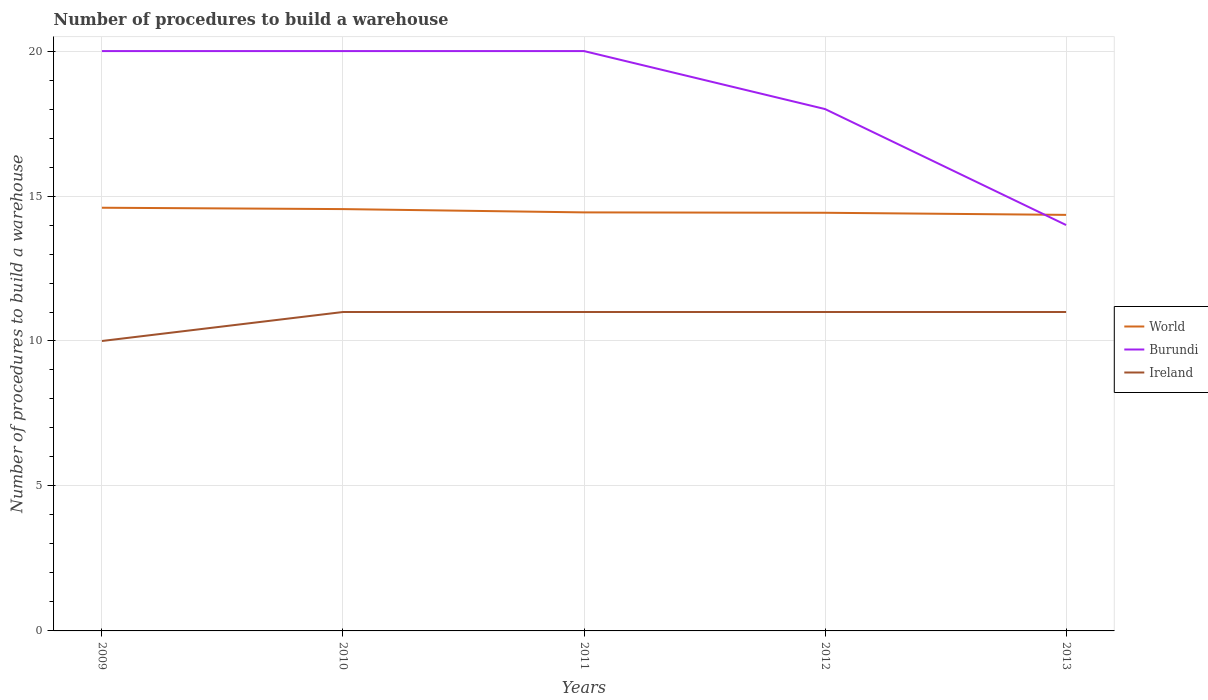How many different coloured lines are there?
Your answer should be compact. 3. Does the line corresponding to Burundi intersect with the line corresponding to World?
Provide a short and direct response. Yes. Is the number of lines equal to the number of legend labels?
Offer a terse response. Yes. Across all years, what is the maximum number of procedures to build a warehouse in in Burundi?
Provide a short and direct response. 14. In which year was the number of procedures to build a warehouse in in World maximum?
Ensure brevity in your answer.  2013. What is the total number of procedures to build a warehouse in in Ireland in the graph?
Offer a very short reply. -1. What is the difference between the highest and the second highest number of procedures to build a warehouse in in Ireland?
Ensure brevity in your answer.  1. Is the number of procedures to build a warehouse in in World strictly greater than the number of procedures to build a warehouse in in Burundi over the years?
Provide a succinct answer. No. How many lines are there?
Ensure brevity in your answer.  3. How many years are there in the graph?
Your answer should be compact. 5. Does the graph contain any zero values?
Provide a short and direct response. No. Does the graph contain grids?
Keep it short and to the point. Yes. What is the title of the graph?
Give a very brief answer. Number of procedures to build a warehouse. Does "St. Lucia" appear as one of the legend labels in the graph?
Your response must be concise. No. What is the label or title of the X-axis?
Make the answer very short. Years. What is the label or title of the Y-axis?
Your answer should be very brief. Number of procedures to build a warehouse. What is the Number of procedures to build a warehouse of World in 2009?
Make the answer very short. 14.6. What is the Number of procedures to build a warehouse of Ireland in 2009?
Make the answer very short. 10. What is the Number of procedures to build a warehouse in World in 2010?
Keep it short and to the point. 14.55. What is the Number of procedures to build a warehouse of Ireland in 2010?
Keep it short and to the point. 11. What is the Number of procedures to build a warehouse in World in 2011?
Keep it short and to the point. 14.44. What is the Number of procedures to build a warehouse in World in 2012?
Your answer should be compact. 14.42. What is the Number of procedures to build a warehouse of World in 2013?
Give a very brief answer. 14.35. What is the Number of procedures to build a warehouse of Ireland in 2013?
Make the answer very short. 11. Across all years, what is the maximum Number of procedures to build a warehouse in World?
Give a very brief answer. 14.6. Across all years, what is the maximum Number of procedures to build a warehouse of Ireland?
Offer a very short reply. 11. Across all years, what is the minimum Number of procedures to build a warehouse of World?
Provide a short and direct response. 14.35. Across all years, what is the minimum Number of procedures to build a warehouse of Ireland?
Offer a very short reply. 10. What is the total Number of procedures to build a warehouse in World in the graph?
Keep it short and to the point. 72.36. What is the total Number of procedures to build a warehouse of Burundi in the graph?
Offer a terse response. 92. What is the difference between the Number of procedures to build a warehouse in World in 2009 and that in 2010?
Ensure brevity in your answer.  0.05. What is the difference between the Number of procedures to build a warehouse in World in 2009 and that in 2011?
Provide a succinct answer. 0.16. What is the difference between the Number of procedures to build a warehouse of Ireland in 2009 and that in 2011?
Make the answer very short. -1. What is the difference between the Number of procedures to build a warehouse of World in 2009 and that in 2012?
Your answer should be compact. 0.17. What is the difference between the Number of procedures to build a warehouse of World in 2009 and that in 2013?
Offer a terse response. 0.25. What is the difference between the Number of procedures to build a warehouse in World in 2010 and that in 2011?
Your answer should be very brief. 0.11. What is the difference between the Number of procedures to build a warehouse of Burundi in 2010 and that in 2011?
Offer a very short reply. 0. What is the difference between the Number of procedures to build a warehouse in Ireland in 2010 and that in 2011?
Keep it short and to the point. 0. What is the difference between the Number of procedures to build a warehouse of World in 2010 and that in 2012?
Your answer should be compact. 0.13. What is the difference between the Number of procedures to build a warehouse in Burundi in 2010 and that in 2012?
Offer a terse response. 2. What is the difference between the Number of procedures to build a warehouse of Ireland in 2010 and that in 2012?
Give a very brief answer. 0. What is the difference between the Number of procedures to build a warehouse in World in 2010 and that in 2013?
Make the answer very short. 0.2. What is the difference between the Number of procedures to build a warehouse in Burundi in 2010 and that in 2013?
Ensure brevity in your answer.  6. What is the difference between the Number of procedures to build a warehouse in World in 2011 and that in 2012?
Offer a very short reply. 0.01. What is the difference between the Number of procedures to build a warehouse of Burundi in 2011 and that in 2012?
Your response must be concise. 2. What is the difference between the Number of procedures to build a warehouse in Ireland in 2011 and that in 2012?
Your answer should be very brief. 0. What is the difference between the Number of procedures to build a warehouse in World in 2011 and that in 2013?
Offer a very short reply. 0.09. What is the difference between the Number of procedures to build a warehouse in Burundi in 2011 and that in 2013?
Provide a short and direct response. 6. What is the difference between the Number of procedures to build a warehouse of World in 2012 and that in 2013?
Keep it short and to the point. 0.07. What is the difference between the Number of procedures to build a warehouse in World in 2009 and the Number of procedures to build a warehouse in Burundi in 2010?
Keep it short and to the point. -5.4. What is the difference between the Number of procedures to build a warehouse in World in 2009 and the Number of procedures to build a warehouse in Ireland in 2010?
Make the answer very short. 3.6. What is the difference between the Number of procedures to build a warehouse in World in 2009 and the Number of procedures to build a warehouse in Burundi in 2011?
Make the answer very short. -5.4. What is the difference between the Number of procedures to build a warehouse in World in 2009 and the Number of procedures to build a warehouse in Ireland in 2011?
Your response must be concise. 3.6. What is the difference between the Number of procedures to build a warehouse of World in 2009 and the Number of procedures to build a warehouse of Burundi in 2012?
Your answer should be very brief. -3.4. What is the difference between the Number of procedures to build a warehouse of World in 2009 and the Number of procedures to build a warehouse of Ireland in 2012?
Give a very brief answer. 3.6. What is the difference between the Number of procedures to build a warehouse in World in 2009 and the Number of procedures to build a warehouse in Burundi in 2013?
Ensure brevity in your answer.  0.6. What is the difference between the Number of procedures to build a warehouse of World in 2009 and the Number of procedures to build a warehouse of Ireland in 2013?
Offer a very short reply. 3.6. What is the difference between the Number of procedures to build a warehouse of Burundi in 2009 and the Number of procedures to build a warehouse of Ireland in 2013?
Offer a very short reply. 9. What is the difference between the Number of procedures to build a warehouse in World in 2010 and the Number of procedures to build a warehouse in Burundi in 2011?
Provide a short and direct response. -5.45. What is the difference between the Number of procedures to build a warehouse of World in 2010 and the Number of procedures to build a warehouse of Ireland in 2011?
Your answer should be compact. 3.55. What is the difference between the Number of procedures to build a warehouse in World in 2010 and the Number of procedures to build a warehouse in Burundi in 2012?
Provide a short and direct response. -3.45. What is the difference between the Number of procedures to build a warehouse of World in 2010 and the Number of procedures to build a warehouse of Ireland in 2012?
Give a very brief answer. 3.55. What is the difference between the Number of procedures to build a warehouse of Burundi in 2010 and the Number of procedures to build a warehouse of Ireland in 2012?
Make the answer very short. 9. What is the difference between the Number of procedures to build a warehouse of World in 2010 and the Number of procedures to build a warehouse of Burundi in 2013?
Offer a very short reply. 0.55. What is the difference between the Number of procedures to build a warehouse of World in 2010 and the Number of procedures to build a warehouse of Ireland in 2013?
Give a very brief answer. 3.55. What is the difference between the Number of procedures to build a warehouse in Burundi in 2010 and the Number of procedures to build a warehouse in Ireland in 2013?
Your answer should be compact. 9. What is the difference between the Number of procedures to build a warehouse in World in 2011 and the Number of procedures to build a warehouse in Burundi in 2012?
Ensure brevity in your answer.  -3.56. What is the difference between the Number of procedures to build a warehouse of World in 2011 and the Number of procedures to build a warehouse of Ireland in 2012?
Offer a very short reply. 3.44. What is the difference between the Number of procedures to build a warehouse in Burundi in 2011 and the Number of procedures to build a warehouse in Ireland in 2012?
Your response must be concise. 9. What is the difference between the Number of procedures to build a warehouse in World in 2011 and the Number of procedures to build a warehouse in Burundi in 2013?
Provide a succinct answer. 0.44. What is the difference between the Number of procedures to build a warehouse of World in 2011 and the Number of procedures to build a warehouse of Ireland in 2013?
Ensure brevity in your answer.  3.44. What is the difference between the Number of procedures to build a warehouse in Burundi in 2011 and the Number of procedures to build a warehouse in Ireland in 2013?
Offer a very short reply. 9. What is the difference between the Number of procedures to build a warehouse of World in 2012 and the Number of procedures to build a warehouse of Burundi in 2013?
Your answer should be very brief. 0.42. What is the difference between the Number of procedures to build a warehouse of World in 2012 and the Number of procedures to build a warehouse of Ireland in 2013?
Offer a terse response. 3.42. What is the average Number of procedures to build a warehouse in World per year?
Keep it short and to the point. 14.47. In the year 2009, what is the difference between the Number of procedures to build a warehouse of World and Number of procedures to build a warehouse of Burundi?
Provide a short and direct response. -5.4. In the year 2009, what is the difference between the Number of procedures to build a warehouse of World and Number of procedures to build a warehouse of Ireland?
Keep it short and to the point. 4.6. In the year 2010, what is the difference between the Number of procedures to build a warehouse of World and Number of procedures to build a warehouse of Burundi?
Your answer should be very brief. -5.45. In the year 2010, what is the difference between the Number of procedures to build a warehouse in World and Number of procedures to build a warehouse in Ireland?
Offer a very short reply. 3.55. In the year 2011, what is the difference between the Number of procedures to build a warehouse in World and Number of procedures to build a warehouse in Burundi?
Make the answer very short. -5.56. In the year 2011, what is the difference between the Number of procedures to build a warehouse of World and Number of procedures to build a warehouse of Ireland?
Your answer should be compact. 3.44. In the year 2012, what is the difference between the Number of procedures to build a warehouse in World and Number of procedures to build a warehouse in Burundi?
Your response must be concise. -3.58. In the year 2012, what is the difference between the Number of procedures to build a warehouse in World and Number of procedures to build a warehouse in Ireland?
Your response must be concise. 3.42. In the year 2012, what is the difference between the Number of procedures to build a warehouse in Burundi and Number of procedures to build a warehouse in Ireland?
Offer a very short reply. 7. In the year 2013, what is the difference between the Number of procedures to build a warehouse of World and Number of procedures to build a warehouse of Burundi?
Your answer should be very brief. 0.35. In the year 2013, what is the difference between the Number of procedures to build a warehouse of World and Number of procedures to build a warehouse of Ireland?
Keep it short and to the point. 3.35. In the year 2013, what is the difference between the Number of procedures to build a warehouse of Burundi and Number of procedures to build a warehouse of Ireland?
Make the answer very short. 3. What is the ratio of the Number of procedures to build a warehouse in World in 2009 to that in 2010?
Offer a very short reply. 1. What is the ratio of the Number of procedures to build a warehouse in World in 2009 to that in 2011?
Your answer should be very brief. 1.01. What is the ratio of the Number of procedures to build a warehouse of Ireland in 2009 to that in 2011?
Provide a short and direct response. 0.91. What is the ratio of the Number of procedures to build a warehouse of World in 2009 to that in 2012?
Your answer should be very brief. 1.01. What is the ratio of the Number of procedures to build a warehouse of Ireland in 2009 to that in 2012?
Offer a terse response. 0.91. What is the ratio of the Number of procedures to build a warehouse of World in 2009 to that in 2013?
Give a very brief answer. 1.02. What is the ratio of the Number of procedures to build a warehouse of Burundi in 2009 to that in 2013?
Give a very brief answer. 1.43. What is the ratio of the Number of procedures to build a warehouse of World in 2010 to that in 2011?
Ensure brevity in your answer.  1.01. What is the ratio of the Number of procedures to build a warehouse in World in 2010 to that in 2012?
Provide a succinct answer. 1.01. What is the ratio of the Number of procedures to build a warehouse in Burundi in 2010 to that in 2012?
Keep it short and to the point. 1.11. What is the ratio of the Number of procedures to build a warehouse of Ireland in 2010 to that in 2012?
Offer a very short reply. 1. What is the ratio of the Number of procedures to build a warehouse of World in 2010 to that in 2013?
Your answer should be compact. 1.01. What is the ratio of the Number of procedures to build a warehouse in Burundi in 2010 to that in 2013?
Offer a terse response. 1.43. What is the ratio of the Number of procedures to build a warehouse of Ireland in 2010 to that in 2013?
Provide a succinct answer. 1. What is the ratio of the Number of procedures to build a warehouse in Burundi in 2011 to that in 2012?
Offer a terse response. 1.11. What is the ratio of the Number of procedures to build a warehouse in World in 2011 to that in 2013?
Offer a terse response. 1.01. What is the ratio of the Number of procedures to build a warehouse in Burundi in 2011 to that in 2013?
Give a very brief answer. 1.43. What is the ratio of the Number of procedures to build a warehouse of Ireland in 2011 to that in 2013?
Your response must be concise. 1. What is the ratio of the Number of procedures to build a warehouse of World in 2012 to that in 2013?
Make the answer very short. 1.01. What is the ratio of the Number of procedures to build a warehouse of Burundi in 2012 to that in 2013?
Offer a terse response. 1.29. What is the ratio of the Number of procedures to build a warehouse of Ireland in 2012 to that in 2013?
Make the answer very short. 1. What is the difference between the highest and the second highest Number of procedures to build a warehouse in World?
Keep it short and to the point. 0.05. What is the difference between the highest and the lowest Number of procedures to build a warehouse in World?
Your answer should be very brief. 0.25. What is the difference between the highest and the lowest Number of procedures to build a warehouse of Burundi?
Provide a short and direct response. 6. What is the difference between the highest and the lowest Number of procedures to build a warehouse in Ireland?
Your answer should be compact. 1. 